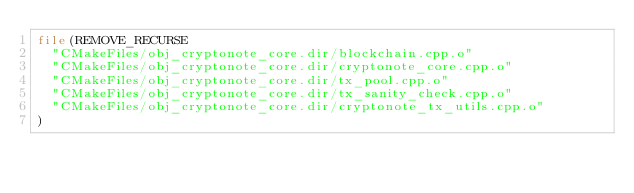Convert code to text. <code><loc_0><loc_0><loc_500><loc_500><_CMake_>file(REMOVE_RECURSE
  "CMakeFiles/obj_cryptonote_core.dir/blockchain.cpp.o"
  "CMakeFiles/obj_cryptonote_core.dir/cryptonote_core.cpp.o"
  "CMakeFiles/obj_cryptonote_core.dir/tx_pool.cpp.o"
  "CMakeFiles/obj_cryptonote_core.dir/tx_sanity_check.cpp.o"
  "CMakeFiles/obj_cryptonote_core.dir/cryptonote_tx_utils.cpp.o"
)
</code> 